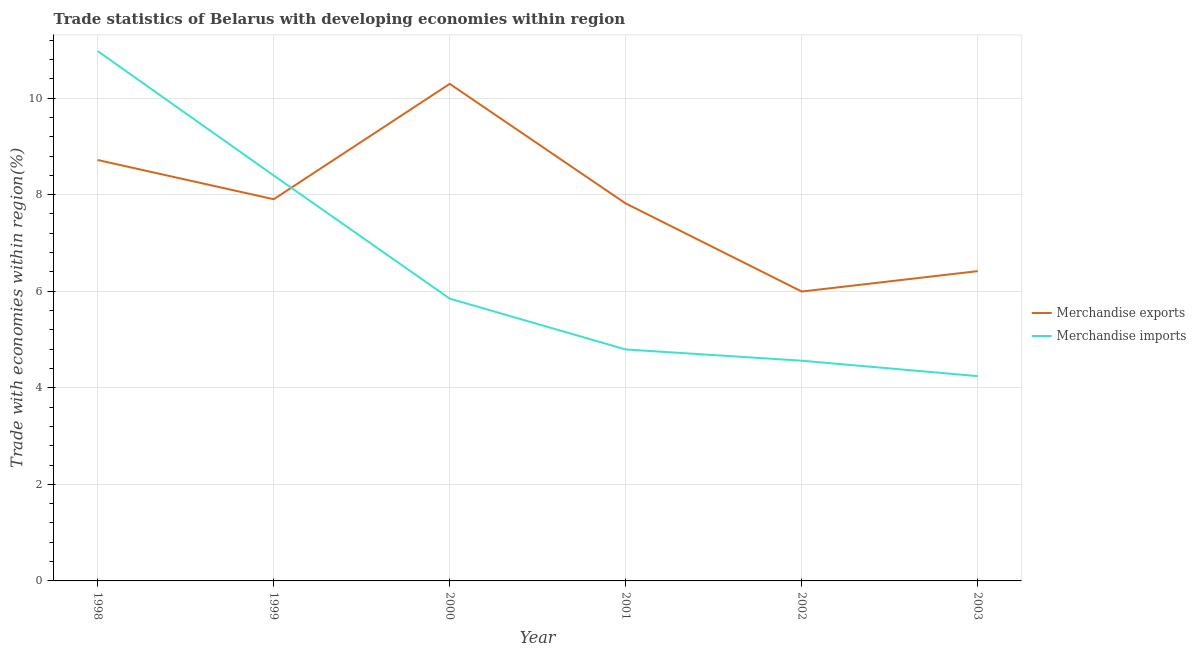Does the line corresponding to merchandise imports intersect with the line corresponding to merchandise exports?
Make the answer very short. Yes. What is the merchandise imports in 2002?
Keep it short and to the point. 4.56. Across all years, what is the maximum merchandise imports?
Your response must be concise. 10.97. Across all years, what is the minimum merchandise imports?
Keep it short and to the point. 4.24. What is the total merchandise imports in the graph?
Your answer should be very brief. 38.81. What is the difference between the merchandise imports in 1999 and that in 2003?
Provide a short and direct response. 4.16. What is the difference between the merchandise imports in 2000 and the merchandise exports in 2001?
Your response must be concise. -1.97. What is the average merchandise imports per year?
Your response must be concise. 6.47. In the year 1998, what is the difference between the merchandise exports and merchandise imports?
Your answer should be very brief. -2.26. What is the ratio of the merchandise imports in 2000 to that in 2001?
Provide a short and direct response. 1.22. What is the difference between the highest and the second highest merchandise exports?
Ensure brevity in your answer.  1.58. What is the difference between the highest and the lowest merchandise exports?
Keep it short and to the point. 4.3. Is the merchandise exports strictly greater than the merchandise imports over the years?
Offer a very short reply. No. How many years are there in the graph?
Make the answer very short. 6. Does the graph contain grids?
Make the answer very short. Yes. Where does the legend appear in the graph?
Keep it short and to the point. Center right. How many legend labels are there?
Offer a very short reply. 2. How are the legend labels stacked?
Make the answer very short. Vertical. What is the title of the graph?
Your answer should be very brief. Trade statistics of Belarus with developing economies within region. What is the label or title of the X-axis?
Offer a very short reply. Year. What is the label or title of the Y-axis?
Provide a succinct answer. Trade with economies within region(%). What is the Trade with economies within region(%) of Merchandise exports in 1998?
Offer a terse response. 8.72. What is the Trade with economies within region(%) of Merchandise imports in 1998?
Your response must be concise. 10.97. What is the Trade with economies within region(%) in Merchandise exports in 1999?
Ensure brevity in your answer.  7.9. What is the Trade with economies within region(%) of Merchandise imports in 1999?
Your response must be concise. 8.4. What is the Trade with economies within region(%) of Merchandise exports in 2000?
Keep it short and to the point. 10.29. What is the Trade with economies within region(%) of Merchandise imports in 2000?
Offer a very short reply. 5.85. What is the Trade with economies within region(%) of Merchandise exports in 2001?
Give a very brief answer. 7.82. What is the Trade with economies within region(%) in Merchandise imports in 2001?
Offer a very short reply. 4.79. What is the Trade with economies within region(%) in Merchandise exports in 2002?
Your answer should be compact. 5.99. What is the Trade with economies within region(%) of Merchandise imports in 2002?
Provide a short and direct response. 4.56. What is the Trade with economies within region(%) of Merchandise exports in 2003?
Provide a succinct answer. 6.42. What is the Trade with economies within region(%) of Merchandise imports in 2003?
Provide a succinct answer. 4.24. Across all years, what is the maximum Trade with economies within region(%) in Merchandise exports?
Make the answer very short. 10.29. Across all years, what is the maximum Trade with economies within region(%) of Merchandise imports?
Ensure brevity in your answer.  10.97. Across all years, what is the minimum Trade with economies within region(%) in Merchandise exports?
Keep it short and to the point. 5.99. Across all years, what is the minimum Trade with economies within region(%) of Merchandise imports?
Provide a short and direct response. 4.24. What is the total Trade with economies within region(%) in Merchandise exports in the graph?
Provide a succinct answer. 47.14. What is the total Trade with economies within region(%) of Merchandise imports in the graph?
Provide a succinct answer. 38.81. What is the difference between the Trade with economies within region(%) in Merchandise exports in 1998 and that in 1999?
Provide a short and direct response. 0.81. What is the difference between the Trade with economies within region(%) of Merchandise imports in 1998 and that in 1999?
Make the answer very short. 2.58. What is the difference between the Trade with economies within region(%) of Merchandise exports in 1998 and that in 2000?
Ensure brevity in your answer.  -1.58. What is the difference between the Trade with economies within region(%) in Merchandise imports in 1998 and that in 2000?
Provide a short and direct response. 5.13. What is the difference between the Trade with economies within region(%) of Merchandise exports in 1998 and that in 2001?
Offer a very short reply. 0.9. What is the difference between the Trade with economies within region(%) of Merchandise imports in 1998 and that in 2001?
Keep it short and to the point. 6.18. What is the difference between the Trade with economies within region(%) in Merchandise exports in 1998 and that in 2002?
Provide a short and direct response. 2.72. What is the difference between the Trade with economies within region(%) of Merchandise imports in 1998 and that in 2002?
Your answer should be very brief. 6.41. What is the difference between the Trade with economies within region(%) of Merchandise exports in 1998 and that in 2003?
Offer a terse response. 2.3. What is the difference between the Trade with economies within region(%) in Merchandise imports in 1998 and that in 2003?
Your response must be concise. 6.73. What is the difference between the Trade with economies within region(%) in Merchandise exports in 1999 and that in 2000?
Offer a terse response. -2.39. What is the difference between the Trade with economies within region(%) of Merchandise imports in 1999 and that in 2000?
Your response must be concise. 2.55. What is the difference between the Trade with economies within region(%) in Merchandise exports in 1999 and that in 2001?
Give a very brief answer. 0.09. What is the difference between the Trade with economies within region(%) of Merchandise imports in 1999 and that in 2001?
Offer a terse response. 3.6. What is the difference between the Trade with economies within region(%) of Merchandise exports in 1999 and that in 2002?
Provide a succinct answer. 1.91. What is the difference between the Trade with economies within region(%) in Merchandise imports in 1999 and that in 2002?
Make the answer very short. 3.84. What is the difference between the Trade with economies within region(%) in Merchandise exports in 1999 and that in 2003?
Your answer should be very brief. 1.49. What is the difference between the Trade with economies within region(%) of Merchandise imports in 1999 and that in 2003?
Offer a terse response. 4.16. What is the difference between the Trade with economies within region(%) in Merchandise exports in 2000 and that in 2001?
Keep it short and to the point. 2.48. What is the difference between the Trade with economies within region(%) in Merchandise imports in 2000 and that in 2001?
Provide a short and direct response. 1.05. What is the difference between the Trade with economies within region(%) of Merchandise exports in 2000 and that in 2002?
Offer a terse response. 4.3. What is the difference between the Trade with economies within region(%) in Merchandise imports in 2000 and that in 2002?
Make the answer very short. 1.29. What is the difference between the Trade with economies within region(%) of Merchandise exports in 2000 and that in 2003?
Keep it short and to the point. 3.88. What is the difference between the Trade with economies within region(%) of Merchandise imports in 2000 and that in 2003?
Keep it short and to the point. 1.61. What is the difference between the Trade with economies within region(%) in Merchandise exports in 2001 and that in 2002?
Provide a succinct answer. 1.82. What is the difference between the Trade with economies within region(%) of Merchandise imports in 2001 and that in 2002?
Provide a succinct answer. 0.23. What is the difference between the Trade with economies within region(%) in Merchandise exports in 2001 and that in 2003?
Your answer should be very brief. 1.4. What is the difference between the Trade with economies within region(%) in Merchandise imports in 2001 and that in 2003?
Offer a very short reply. 0.55. What is the difference between the Trade with economies within region(%) of Merchandise exports in 2002 and that in 2003?
Provide a short and direct response. -0.42. What is the difference between the Trade with economies within region(%) of Merchandise imports in 2002 and that in 2003?
Provide a succinct answer. 0.32. What is the difference between the Trade with economies within region(%) in Merchandise exports in 1998 and the Trade with economies within region(%) in Merchandise imports in 1999?
Offer a very short reply. 0.32. What is the difference between the Trade with economies within region(%) in Merchandise exports in 1998 and the Trade with economies within region(%) in Merchandise imports in 2000?
Your answer should be very brief. 2.87. What is the difference between the Trade with economies within region(%) in Merchandise exports in 1998 and the Trade with economies within region(%) in Merchandise imports in 2001?
Your answer should be compact. 3.92. What is the difference between the Trade with economies within region(%) in Merchandise exports in 1998 and the Trade with economies within region(%) in Merchandise imports in 2002?
Ensure brevity in your answer.  4.16. What is the difference between the Trade with economies within region(%) in Merchandise exports in 1998 and the Trade with economies within region(%) in Merchandise imports in 2003?
Your answer should be very brief. 4.48. What is the difference between the Trade with economies within region(%) in Merchandise exports in 1999 and the Trade with economies within region(%) in Merchandise imports in 2000?
Your response must be concise. 2.06. What is the difference between the Trade with economies within region(%) in Merchandise exports in 1999 and the Trade with economies within region(%) in Merchandise imports in 2001?
Ensure brevity in your answer.  3.11. What is the difference between the Trade with economies within region(%) in Merchandise exports in 1999 and the Trade with economies within region(%) in Merchandise imports in 2002?
Your answer should be compact. 3.34. What is the difference between the Trade with economies within region(%) in Merchandise exports in 1999 and the Trade with economies within region(%) in Merchandise imports in 2003?
Your answer should be compact. 3.66. What is the difference between the Trade with economies within region(%) of Merchandise exports in 2000 and the Trade with economies within region(%) of Merchandise imports in 2001?
Your answer should be compact. 5.5. What is the difference between the Trade with economies within region(%) of Merchandise exports in 2000 and the Trade with economies within region(%) of Merchandise imports in 2002?
Your answer should be very brief. 5.73. What is the difference between the Trade with economies within region(%) in Merchandise exports in 2000 and the Trade with economies within region(%) in Merchandise imports in 2003?
Your answer should be very brief. 6.05. What is the difference between the Trade with economies within region(%) of Merchandise exports in 2001 and the Trade with economies within region(%) of Merchandise imports in 2002?
Offer a terse response. 3.26. What is the difference between the Trade with economies within region(%) in Merchandise exports in 2001 and the Trade with economies within region(%) in Merchandise imports in 2003?
Provide a short and direct response. 3.58. What is the difference between the Trade with economies within region(%) in Merchandise exports in 2002 and the Trade with economies within region(%) in Merchandise imports in 2003?
Your answer should be very brief. 1.75. What is the average Trade with economies within region(%) of Merchandise exports per year?
Your answer should be compact. 7.86. What is the average Trade with economies within region(%) of Merchandise imports per year?
Your answer should be very brief. 6.47. In the year 1998, what is the difference between the Trade with economies within region(%) in Merchandise exports and Trade with economies within region(%) in Merchandise imports?
Give a very brief answer. -2.26. In the year 1999, what is the difference between the Trade with economies within region(%) in Merchandise exports and Trade with economies within region(%) in Merchandise imports?
Offer a terse response. -0.49. In the year 2000, what is the difference between the Trade with economies within region(%) in Merchandise exports and Trade with economies within region(%) in Merchandise imports?
Ensure brevity in your answer.  4.45. In the year 2001, what is the difference between the Trade with economies within region(%) in Merchandise exports and Trade with economies within region(%) in Merchandise imports?
Keep it short and to the point. 3.02. In the year 2002, what is the difference between the Trade with economies within region(%) of Merchandise exports and Trade with economies within region(%) of Merchandise imports?
Keep it short and to the point. 1.43. In the year 2003, what is the difference between the Trade with economies within region(%) of Merchandise exports and Trade with economies within region(%) of Merchandise imports?
Give a very brief answer. 2.17. What is the ratio of the Trade with economies within region(%) in Merchandise exports in 1998 to that in 1999?
Keep it short and to the point. 1.1. What is the ratio of the Trade with economies within region(%) of Merchandise imports in 1998 to that in 1999?
Your answer should be very brief. 1.31. What is the ratio of the Trade with economies within region(%) of Merchandise exports in 1998 to that in 2000?
Ensure brevity in your answer.  0.85. What is the ratio of the Trade with economies within region(%) of Merchandise imports in 1998 to that in 2000?
Your answer should be compact. 1.88. What is the ratio of the Trade with economies within region(%) of Merchandise exports in 1998 to that in 2001?
Provide a short and direct response. 1.12. What is the ratio of the Trade with economies within region(%) of Merchandise imports in 1998 to that in 2001?
Keep it short and to the point. 2.29. What is the ratio of the Trade with economies within region(%) of Merchandise exports in 1998 to that in 2002?
Provide a short and direct response. 1.45. What is the ratio of the Trade with economies within region(%) in Merchandise imports in 1998 to that in 2002?
Your answer should be very brief. 2.41. What is the ratio of the Trade with economies within region(%) in Merchandise exports in 1998 to that in 2003?
Your answer should be very brief. 1.36. What is the ratio of the Trade with economies within region(%) of Merchandise imports in 1998 to that in 2003?
Give a very brief answer. 2.59. What is the ratio of the Trade with economies within region(%) in Merchandise exports in 1999 to that in 2000?
Offer a very short reply. 0.77. What is the ratio of the Trade with economies within region(%) in Merchandise imports in 1999 to that in 2000?
Offer a very short reply. 1.44. What is the ratio of the Trade with economies within region(%) of Merchandise exports in 1999 to that in 2001?
Your answer should be compact. 1.01. What is the ratio of the Trade with economies within region(%) of Merchandise imports in 1999 to that in 2001?
Give a very brief answer. 1.75. What is the ratio of the Trade with economies within region(%) of Merchandise exports in 1999 to that in 2002?
Give a very brief answer. 1.32. What is the ratio of the Trade with economies within region(%) of Merchandise imports in 1999 to that in 2002?
Give a very brief answer. 1.84. What is the ratio of the Trade with economies within region(%) of Merchandise exports in 1999 to that in 2003?
Give a very brief answer. 1.23. What is the ratio of the Trade with economies within region(%) in Merchandise imports in 1999 to that in 2003?
Provide a short and direct response. 1.98. What is the ratio of the Trade with economies within region(%) in Merchandise exports in 2000 to that in 2001?
Keep it short and to the point. 1.32. What is the ratio of the Trade with economies within region(%) of Merchandise imports in 2000 to that in 2001?
Provide a succinct answer. 1.22. What is the ratio of the Trade with economies within region(%) in Merchandise exports in 2000 to that in 2002?
Your answer should be compact. 1.72. What is the ratio of the Trade with economies within region(%) of Merchandise imports in 2000 to that in 2002?
Provide a succinct answer. 1.28. What is the ratio of the Trade with economies within region(%) of Merchandise exports in 2000 to that in 2003?
Your response must be concise. 1.6. What is the ratio of the Trade with economies within region(%) of Merchandise imports in 2000 to that in 2003?
Give a very brief answer. 1.38. What is the ratio of the Trade with economies within region(%) of Merchandise exports in 2001 to that in 2002?
Keep it short and to the point. 1.3. What is the ratio of the Trade with economies within region(%) of Merchandise imports in 2001 to that in 2002?
Give a very brief answer. 1.05. What is the ratio of the Trade with economies within region(%) in Merchandise exports in 2001 to that in 2003?
Your answer should be compact. 1.22. What is the ratio of the Trade with economies within region(%) in Merchandise imports in 2001 to that in 2003?
Provide a succinct answer. 1.13. What is the ratio of the Trade with economies within region(%) of Merchandise exports in 2002 to that in 2003?
Offer a terse response. 0.93. What is the ratio of the Trade with economies within region(%) of Merchandise imports in 2002 to that in 2003?
Your response must be concise. 1.08. What is the difference between the highest and the second highest Trade with economies within region(%) in Merchandise exports?
Provide a succinct answer. 1.58. What is the difference between the highest and the second highest Trade with economies within region(%) of Merchandise imports?
Your response must be concise. 2.58. What is the difference between the highest and the lowest Trade with economies within region(%) of Merchandise exports?
Keep it short and to the point. 4.3. What is the difference between the highest and the lowest Trade with economies within region(%) in Merchandise imports?
Your response must be concise. 6.73. 